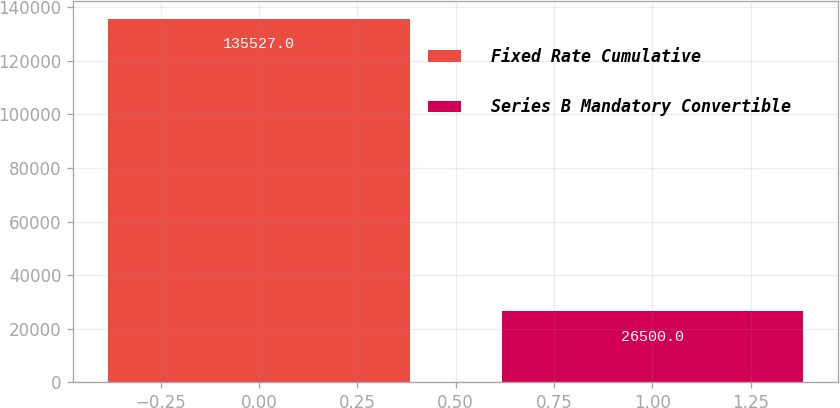Convert chart. <chart><loc_0><loc_0><loc_500><loc_500><bar_chart><fcel>Fixed Rate Cumulative<fcel>Series B Mandatory Convertible<nl><fcel>135527<fcel>26500<nl></chart> 